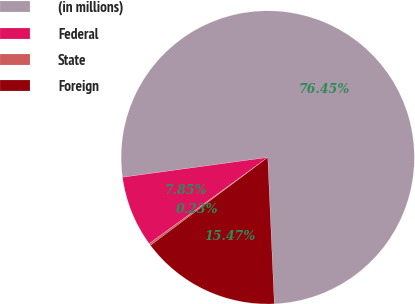Convert chart. <chart><loc_0><loc_0><loc_500><loc_500><pie_chart><fcel>(in millions)<fcel>Federal<fcel>State<fcel>Foreign<nl><fcel>76.45%<fcel>7.85%<fcel>0.23%<fcel>15.47%<nl></chart> 